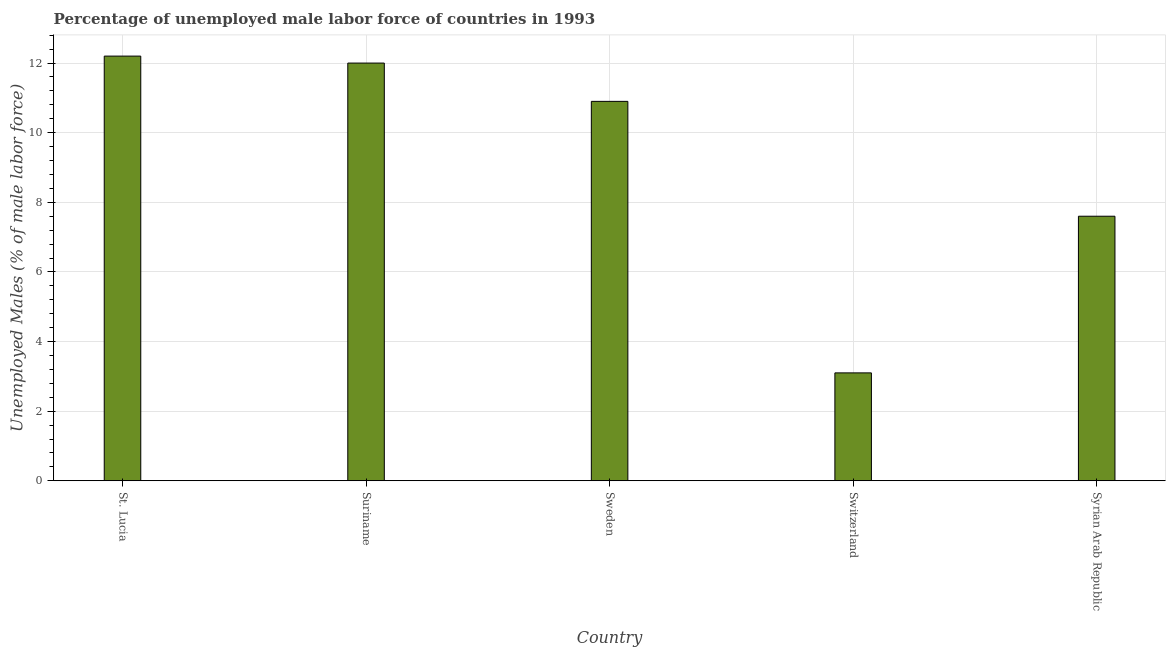Does the graph contain any zero values?
Your answer should be very brief. No. What is the title of the graph?
Provide a short and direct response. Percentage of unemployed male labor force of countries in 1993. What is the label or title of the X-axis?
Offer a terse response. Country. What is the label or title of the Y-axis?
Offer a terse response. Unemployed Males (% of male labor force). What is the total unemployed male labour force in Syrian Arab Republic?
Your answer should be very brief. 7.6. Across all countries, what is the maximum total unemployed male labour force?
Ensure brevity in your answer.  12.2. Across all countries, what is the minimum total unemployed male labour force?
Keep it short and to the point. 3.1. In which country was the total unemployed male labour force maximum?
Provide a succinct answer. St. Lucia. In which country was the total unemployed male labour force minimum?
Your response must be concise. Switzerland. What is the sum of the total unemployed male labour force?
Your response must be concise. 45.8. What is the average total unemployed male labour force per country?
Your response must be concise. 9.16. What is the median total unemployed male labour force?
Ensure brevity in your answer.  10.9. In how many countries, is the total unemployed male labour force greater than 4 %?
Provide a succinct answer. 4. What is the ratio of the total unemployed male labour force in Sweden to that in Syrian Arab Republic?
Provide a succinct answer. 1.43. Is the total unemployed male labour force in Sweden less than that in Syrian Arab Republic?
Your response must be concise. No. What is the difference between the highest and the second highest total unemployed male labour force?
Your answer should be compact. 0.2. Is the sum of the total unemployed male labour force in St. Lucia and Sweden greater than the maximum total unemployed male labour force across all countries?
Your response must be concise. Yes. In how many countries, is the total unemployed male labour force greater than the average total unemployed male labour force taken over all countries?
Offer a terse response. 3. Are all the bars in the graph horizontal?
Make the answer very short. No. How many countries are there in the graph?
Your answer should be very brief. 5. What is the difference between two consecutive major ticks on the Y-axis?
Offer a terse response. 2. Are the values on the major ticks of Y-axis written in scientific E-notation?
Offer a terse response. No. What is the Unemployed Males (% of male labor force) in St. Lucia?
Offer a terse response. 12.2. What is the Unemployed Males (% of male labor force) of Sweden?
Offer a very short reply. 10.9. What is the Unemployed Males (% of male labor force) in Switzerland?
Provide a short and direct response. 3.1. What is the Unemployed Males (% of male labor force) of Syrian Arab Republic?
Ensure brevity in your answer.  7.6. What is the difference between the Unemployed Males (% of male labor force) in St. Lucia and Suriname?
Offer a terse response. 0.2. What is the difference between the Unemployed Males (% of male labor force) in St. Lucia and Sweden?
Keep it short and to the point. 1.3. What is the difference between the Unemployed Males (% of male labor force) in St. Lucia and Switzerland?
Keep it short and to the point. 9.1. What is the difference between the Unemployed Males (% of male labor force) in Suriname and Sweden?
Make the answer very short. 1.1. What is the difference between the Unemployed Males (% of male labor force) in Suriname and Switzerland?
Offer a very short reply. 8.9. What is the difference between the Unemployed Males (% of male labor force) in Switzerland and Syrian Arab Republic?
Give a very brief answer. -4.5. What is the ratio of the Unemployed Males (% of male labor force) in St. Lucia to that in Sweden?
Offer a very short reply. 1.12. What is the ratio of the Unemployed Males (% of male labor force) in St. Lucia to that in Switzerland?
Give a very brief answer. 3.94. What is the ratio of the Unemployed Males (% of male labor force) in St. Lucia to that in Syrian Arab Republic?
Your answer should be very brief. 1.6. What is the ratio of the Unemployed Males (% of male labor force) in Suriname to that in Sweden?
Offer a terse response. 1.1. What is the ratio of the Unemployed Males (% of male labor force) in Suriname to that in Switzerland?
Offer a terse response. 3.87. What is the ratio of the Unemployed Males (% of male labor force) in Suriname to that in Syrian Arab Republic?
Your answer should be compact. 1.58. What is the ratio of the Unemployed Males (% of male labor force) in Sweden to that in Switzerland?
Give a very brief answer. 3.52. What is the ratio of the Unemployed Males (% of male labor force) in Sweden to that in Syrian Arab Republic?
Provide a succinct answer. 1.43. What is the ratio of the Unemployed Males (% of male labor force) in Switzerland to that in Syrian Arab Republic?
Make the answer very short. 0.41. 